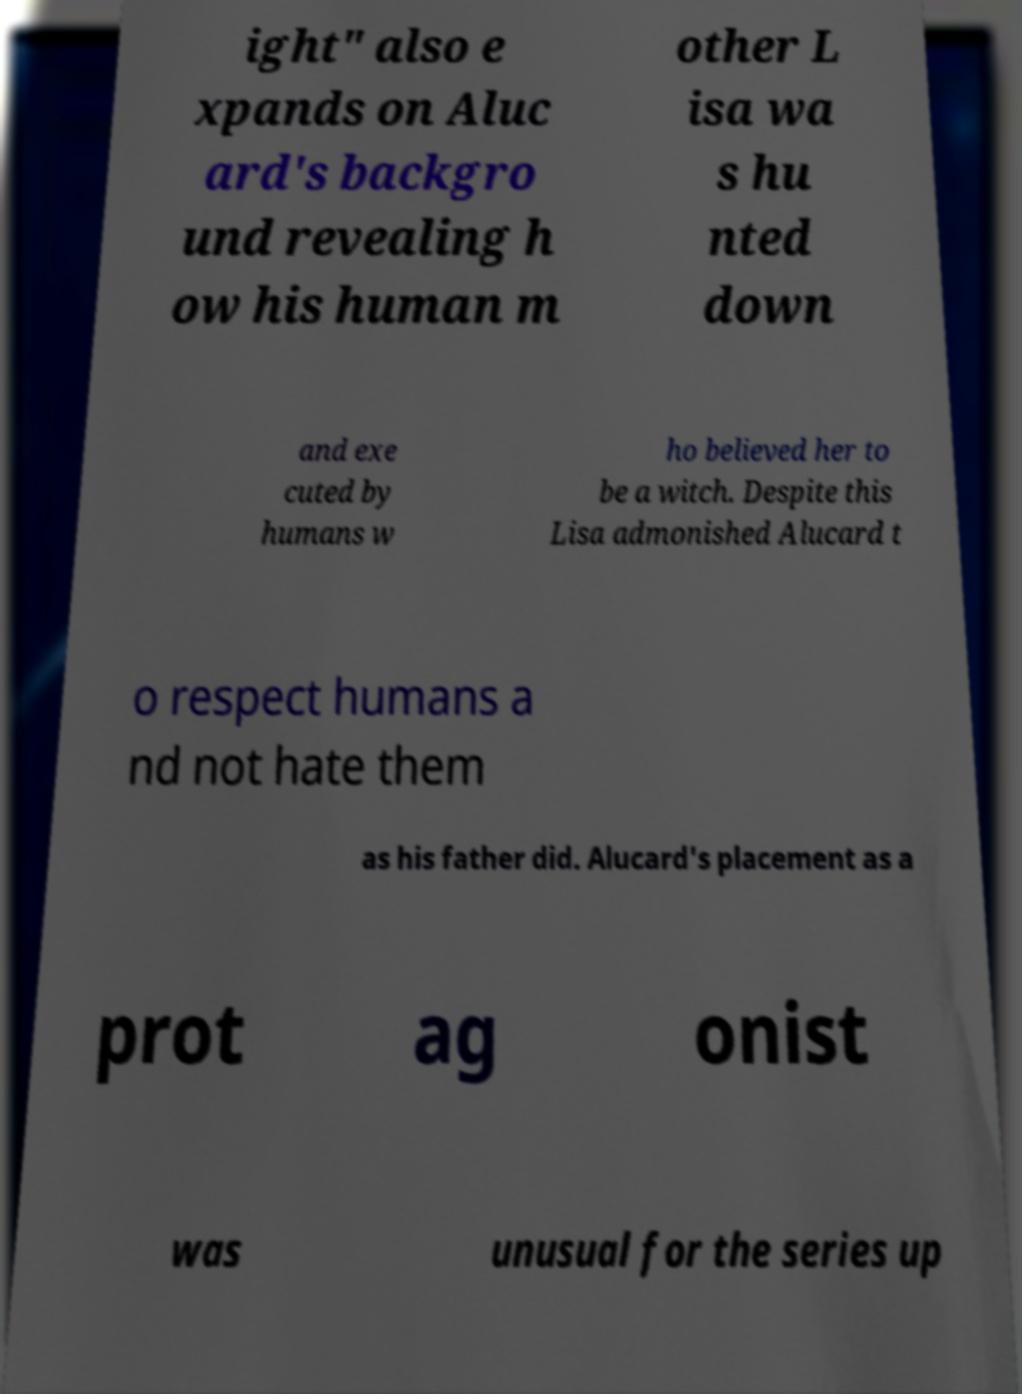Can you accurately transcribe the text from the provided image for me? ight" also e xpands on Aluc ard's backgro und revealing h ow his human m other L isa wa s hu nted down and exe cuted by humans w ho believed her to be a witch. Despite this Lisa admonished Alucard t o respect humans a nd not hate them as his father did. Alucard's placement as a prot ag onist was unusual for the series up 